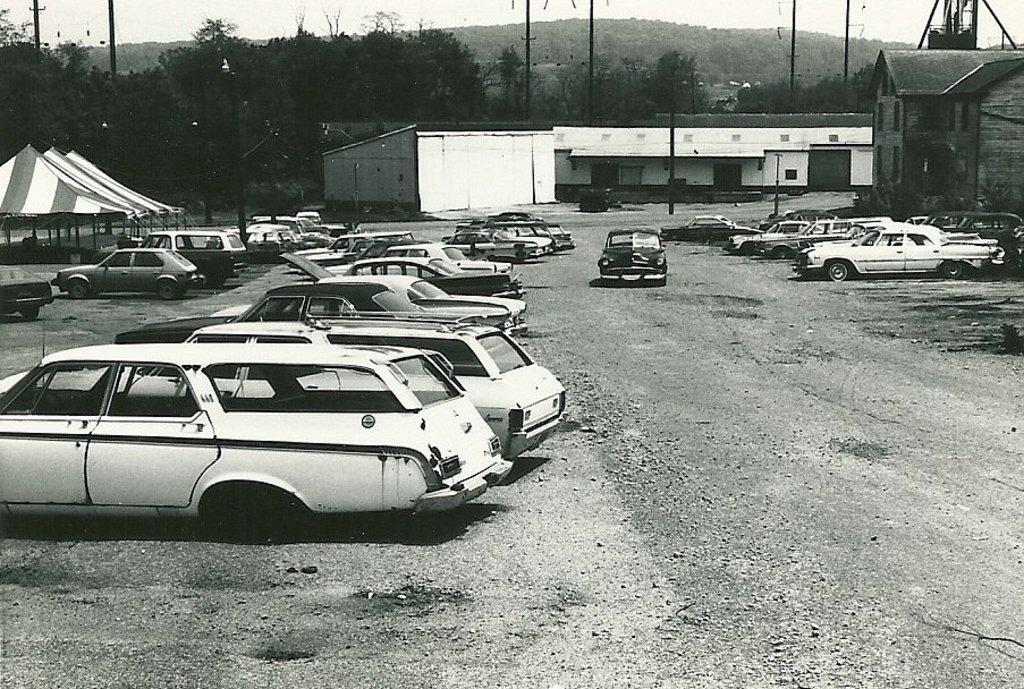What is the color scheme of the image? The image is black and white. What can be seen on the land in the image? There are cars parked on the land in the image. What is visible in the background of the image? There are buildings, tents, trees, and fencing in the background of the image. What type of bait is being used to catch fish in the image? There is no fishing or bait present in the image; it features parked cars, buildings, tents, trees, and fencing. What kind of nut can be seen growing on the trees in the image? There is no nut-bearing tree visible in the image; only the trees themselves are present. 